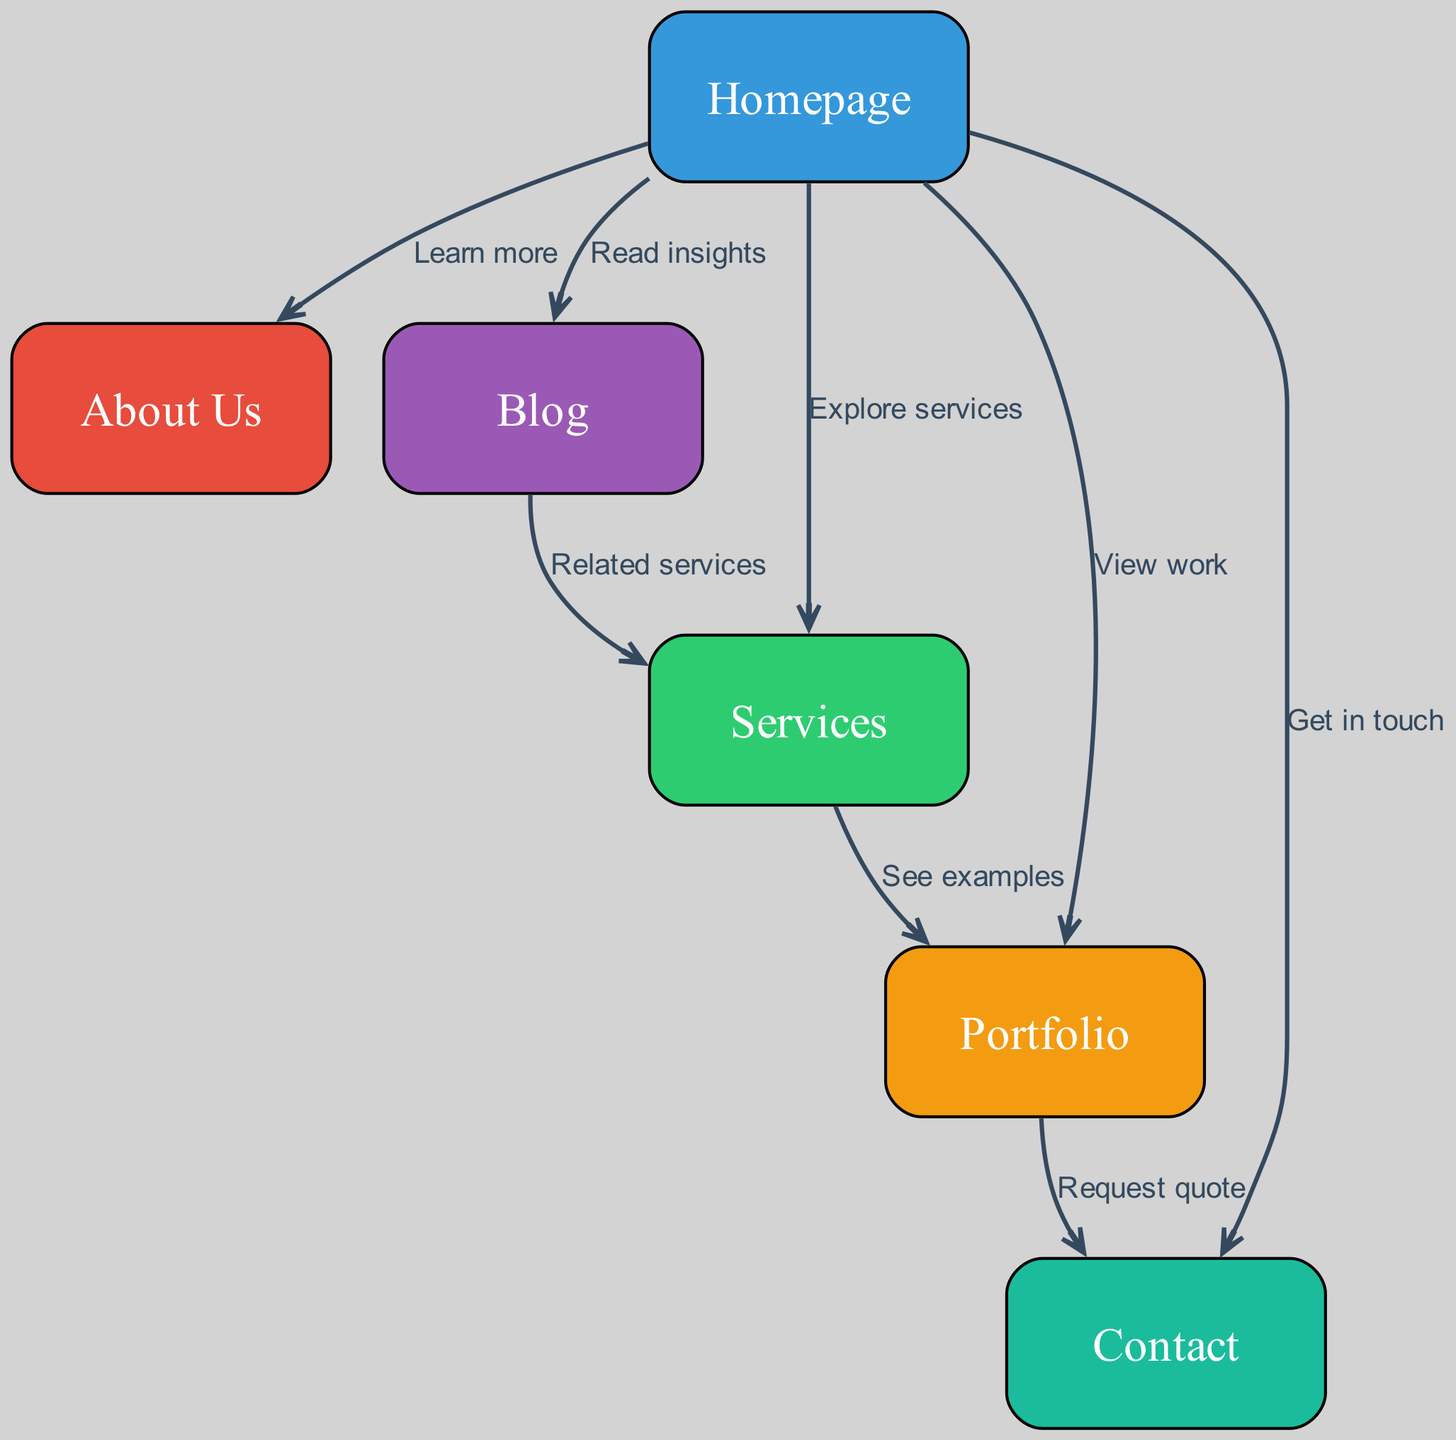What is the total number of nodes in the diagram? Counting the nodes listed in the data, we find "homepage," "about," "services," "portfolio," "blog," and "contact." This gives us a total of 6 nodes.
Answer: 6 Which node has the edge labeled "Get in touch"? Looking at the edges in the diagram, the edge labeled "Get in touch" points from "homepage" to "contact." Therefore, "contact" is the node with this edge.
Answer: Contact What is the relationship between "services" and "portfolio"? The edge connecting "services" to "portfolio" is labeled "See examples." This indicates that there is a direct link between these two nodes with this specific relationship.
Answer: See examples How many edges are there in total? Counting the edges listed in the data, we have edges connecting various nodes, and there are 8 edges in total.
Answer: 8 Which node does the "blog" connect to with the edge labeled "Related services"? The edge labeled "Related services" connects "blog" to "services." This indicates that the "blog" node leads directly to the "services" node.
Answer: Services If a user selects "Read insights" from the homepage, which node do they reach next? The edge labeled "Read insights" from the "homepage" connects directly to the "blog" node. Therefore, selecting this option takes the user to the "blog."
Answer: Blog Which nodes can a user access directly from the "homepage"? From the "homepage," a user can access five nodes: "about," "services," "portfolio," "blog," and "contact," as indicated by the edges leading from the homepage.
Answer: About, Services, Portfolio, Blog, Contact What is the path from "portfolio" to "contact"? The path from "portfolio" to "contact" is represented by the edge labeled "Request quote," which leads from "portfolio" directly to "contact."
Answer: Request quote What is the main function of the "services" node in this structure? The "services" node serves as a reference point for both the "portfolio" node (with the edge "See examples") and the "blog" node (with the edge "Related services"), indicating a connection to the offered services.
Answer: Reference point for portfolio and blog 